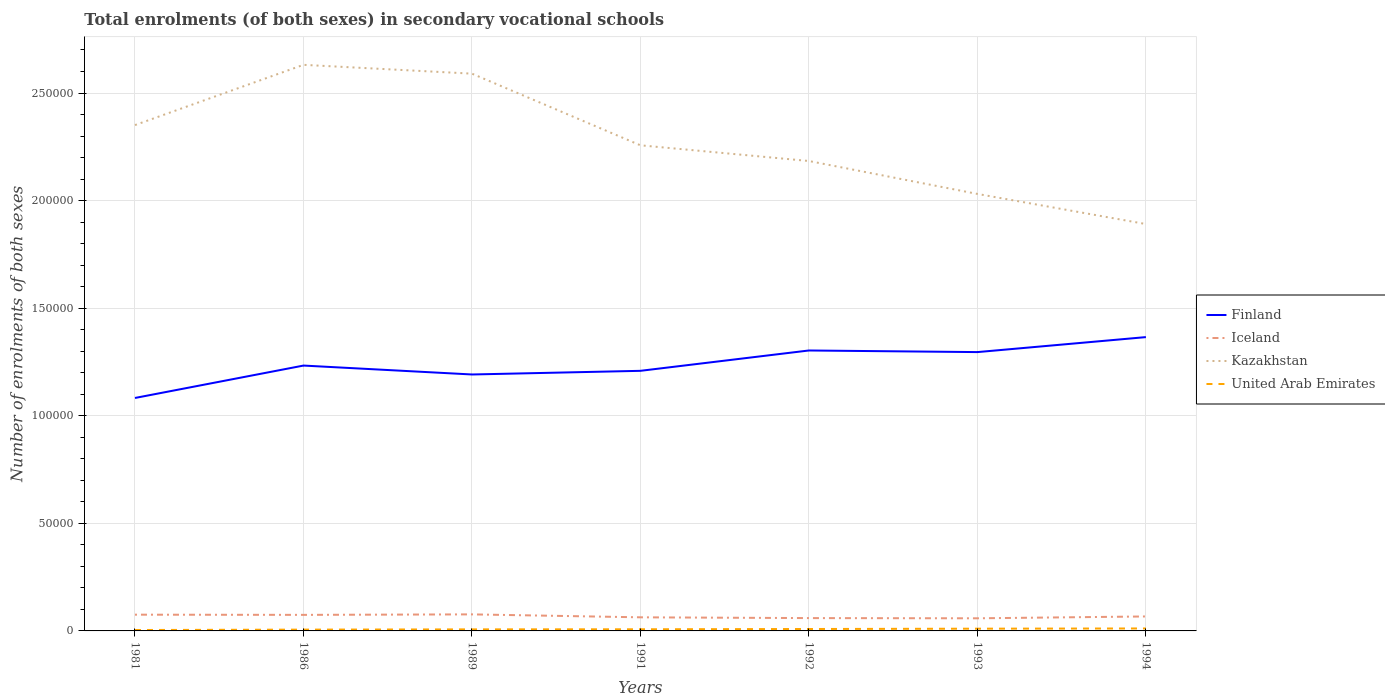How many different coloured lines are there?
Your answer should be very brief. 4. Does the line corresponding to Kazakhstan intersect with the line corresponding to Finland?
Keep it short and to the point. No. Is the number of lines equal to the number of legend labels?
Make the answer very short. Yes. Across all years, what is the maximum number of enrolments in secondary schools in Finland?
Provide a short and direct response. 1.08e+05. In which year was the number of enrolments in secondary schools in Kazakhstan maximum?
Keep it short and to the point. 1994. What is the total number of enrolments in secondary schools in United Arab Emirates in the graph?
Keep it short and to the point. -471. What is the difference between the highest and the second highest number of enrolments in secondary schools in Finland?
Your response must be concise. 2.83e+04. What is the difference between the highest and the lowest number of enrolments in secondary schools in Finland?
Your response must be concise. 3. What is the difference between two consecutive major ticks on the Y-axis?
Your response must be concise. 5.00e+04. How many legend labels are there?
Your answer should be compact. 4. What is the title of the graph?
Offer a very short reply. Total enrolments (of both sexes) in secondary vocational schools. What is the label or title of the Y-axis?
Your response must be concise. Number of enrolments of both sexes. What is the Number of enrolments of both sexes in Finland in 1981?
Your answer should be compact. 1.08e+05. What is the Number of enrolments of both sexes of Iceland in 1981?
Your response must be concise. 7552. What is the Number of enrolments of both sexes in Kazakhstan in 1981?
Provide a short and direct response. 2.35e+05. What is the Number of enrolments of both sexes in United Arab Emirates in 1981?
Offer a very short reply. 422. What is the Number of enrolments of both sexes of Finland in 1986?
Your answer should be very brief. 1.23e+05. What is the Number of enrolments of both sexes in Iceland in 1986?
Provide a succinct answer. 7462. What is the Number of enrolments of both sexes of Kazakhstan in 1986?
Your answer should be very brief. 2.63e+05. What is the Number of enrolments of both sexes of United Arab Emirates in 1986?
Provide a succinct answer. 604. What is the Number of enrolments of both sexes of Finland in 1989?
Ensure brevity in your answer.  1.19e+05. What is the Number of enrolments of both sexes of Iceland in 1989?
Give a very brief answer. 7689. What is the Number of enrolments of both sexes in Kazakhstan in 1989?
Make the answer very short. 2.59e+05. What is the Number of enrolments of both sexes in United Arab Emirates in 1989?
Your answer should be very brief. 720. What is the Number of enrolments of both sexes of Finland in 1991?
Your answer should be compact. 1.21e+05. What is the Number of enrolments of both sexes of Iceland in 1991?
Offer a very short reply. 6322. What is the Number of enrolments of both sexes in Kazakhstan in 1991?
Offer a terse response. 2.26e+05. What is the Number of enrolments of both sexes in United Arab Emirates in 1991?
Provide a short and direct response. 766. What is the Number of enrolments of both sexes of Finland in 1992?
Offer a very short reply. 1.30e+05. What is the Number of enrolments of both sexes of Iceland in 1992?
Provide a short and direct response. 5963. What is the Number of enrolments of both sexes of Kazakhstan in 1992?
Provide a short and direct response. 2.18e+05. What is the Number of enrolments of both sexes of United Arab Emirates in 1992?
Offer a very short reply. 893. What is the Number of enrolments of both sexes of Finland in 1993?
Your answer should be very brief. 1.30e+05. What is the Number of enrolments of both sexes in Iceland in 1993?
Give a very brief answer. 5865. What is the Number of enrolments of both sexes of Kazakhstan in 1993?
Offer a very short reply. 2.03e+05. What is the Number of enrolments of both sexes in United Arab Emirates in 1993?
Give a very brief answer. 1040. What is the Number of enrolments of both sexes in Finland in 1994?
Your answer should be very brief. 1.37e+05. What is the Number of enrolments of both sexes in Iceland in 1994?
Make the answer very short. 6726. What is the Number of enrolments of both sexes of Kazakhstan in 1994?
Offer a terse response. 1.89e+05. What is the Number of enrolments of both sexes of United Arab Emirates in 1994?
Your answer should be compact. 1143. Across all years, what is the maximum Number of enrolments of both sexes of Finland?
Your answer should be compact. 1.37e+05. Across all years, what is the maximum Number of enrolments of both sexes of Iceland?
Your answer should be compact. 7689. Across all years, what is the maximum Number of enrolments of both sexes of Kazakhstan?
Your answer should be compact. 2.63e+05. Across all years, what is the maximum Number of enrolments of both sexes in United Arab Emirates?
Offer a very short reply. 1143. Across all years, what is the minimum Number of enrolments of both sexes of Finland?
Offer a terse response. 1.08e+05. Across all years, what is the minimum Number of enrolments of both sexes in Iceland?
Give a very brief answer. 5865. Across all years, what is the minimum Number of enrolments of both sexes of Kazakhstan?
Keep it short and to the point. 1.89e+05. Across all years, what is the minimum Number of enrolments of both sexes of United Arab Emirates?
Offer a very short reply. 422. What is the total Number of enrolments of both sexes of Finland in the graph?
Offer a terse response. 8.68e+05. What is the total Number of enrolments of both sexes of Iceland in the graph?
Your answer should be very brief. 4.76e+04. What is the total Number of enrolments of both sexes in Kazakhstan in the graph?
Your answer should be very brief. 1.59e+06. What is the total Number of enrolments of both sexes in United Arab Emirates in the graph?
Give a very brief answer. 5588. What is the difference between the Number of enrolments of both sexes in Finland in 1981 and that in 1986?
Make the answer very short. -1.51e+04. What is the difference between the Number of enrolments of both sexes in Iceland in 1981 and that in 1986?
Your answer should be compact. 90. What is the difference between the Number of enrolments of both sexes in Kazakhstan in 1981 and that in 1986?
Make the answer very short. -2.80e+04. What is the difference between the Number of enrolments of both sexes of United Arab Emirates in 1981 and that in 1986?
Provide a succinct answer. -182. What is the difference between the Number of enrolments of both sexes in Finland in 1981 and that in 1989?
Offer a very short reply. -1.09e+04. What is the difference between the Number of enrolments of both sexes in Iceland in 1981 and that in 1989?
Keep it short and to the point. -137. What is the difference between the Number of enrolments of both sexes in Kazakhstan in 1981 and that in 1989?
Provide a succinct answer. -2.39e+04. What is the difference between the Number of enrolments of both sexes in United Arab Emirates in 1981 and that in 1989?
Your answer should be very brief. -298. What is the difference between the Number of enrolments of both sexes of Finland in 1981 and that in 1991?
Ensure brevity in your answer.  -1.26e+04. What is the difference between the Number of enrolments of both sexes in Iceland in 1981 and that in 1991?
Your response must be concise. 1230. What is the difference between the Number of enrolments of both sexes of Kazakhstan in 1981 and that in 1991?
Provide a short and direct response. 9400. What is the difference between the Number of enrolments of both sexes of United Arab Emirates in 1981 and that in 1991?
Offer a terse response. -344. What is the difference between the Number of enrolments of both sexes in Finland in 1981 and that in 1992?
Offer a very short reply. -2.21e+04. What is the difference between the Number of enrolments of both sexes of Iceland in 1981 and that in 1992?
Keep it short and to the point. 1589. What is the difference between the Number of enrolments of both sexes of Kazakhstan in 1981 and that in 1992?
Offer a very short reply. 1.67e+04. What is the difference between the Number of enrolments of both sexes of United Arab Emirates in 1981 and that in 1992?
Your answer should be compact. -471. What is the difference between the Number of enrolments of both sexes in Finland in 1981 and that in 1993?
Make the answer very short. -2.13e+04. What is the difference between the Number of enrolments of both sexes in Iceland in 1981 and that in 1993?
Give a very brief answer. 1687. What is the difference between the Number of enrolments of both sexes of Kazakhstan in 1981 and that in 1993?
Ensure brevity in your answer.  3.20e+04. What is the difference between the Number of enrolments of both sexes of United Arab Emirates in 1981 and that in 1993?
Ensure brevity in your answer.  -618. What is the difference between the Number of enrolments of both sexes of Finland in 1981 and that in 1994?
Your response must be concise. -2.83e+04. What is the difference between the Number of enrolments of both sexes in Iceland in 1981 and that in 1994?
Your answer should be very brief. 826. What is the difference between the Number of enrolments of both sexes of Kazakhstan in 1981 and that in 1994?
Offer a very short reply. 4.60e+04. What is the difference between the Number of enrolments of both sexes in United Arab Emirates in 1981 and that in 1994?
Give a very brief answer. -721. What is the difference between the Number of enrolments of both sexes of Finland in 1986 and that in 1989?
Give a very brief answer. 4141. What is the difference between the Number of enrolments of both sexes of Iceland in 1986 and that in 1989?
Ensure brevity in your answer.  -227. What is the difference between the Number of enrolments of both sexes of Kazakhstan in 1986 and that in 1989?
Your response must be concise. 4100. What is the difference between the Number of enrolments of both sexes of United Arab Emirates in 1986 and that in 1989?
Ensure brevity in your answer.  -116. What is the difference between the Number of enrolments of both sexes in Finland in 1986 and that in 1991?
Provide a short and direct response. 2443. What is the difference between the Number of enrolments of both sexes in Iceland in 1986 and that in 1991?
Your answer should be compact. 1140. What is the difference between the Number of enrolments of both sexes of Kazakhstan in 1986 and that in 1991?
Provide a succinct answer. 3.74e+04. What is the difference between the Number of enrolments of both sexes of United Arab Emirates in 1986 and that in 1991?
Keep it short and to the point. -162. What is the difference between the Number of enrolments of both sexes in Finland in 1986 and that in 1992?
Offer a very short reply. -7013. What is the difference between the Number of enrolments of both sexes of Iceland in 1986 and that in 1992?
Provide a succinct answer. 1499. What is the difference between the Number of enrolments of both sexes of Kazakhstan in 1986 and that in 1992?
Make the answer very short. 4.47e+04. What is the difference between the Number of enrolments of both sexes of United Arab Emirates in 1986 and that in 1992?
Your answer should be very brief. -289. What is the difference between the Number of enrolments of both sexes of Finland in 1986 and that in 1993?
Ensure brevity in your answer.  -6261. What is the difference between the Number of enrolments of both sexes in Iceland in 1986 and that in 1993?
Give a very brief answer. 1597. What is the difference between the Number of enrolments of both sexes of Kazakhstan in 1986 and that in 1993?
Keep it short and to the point. 6.00e+04. What is the difference between the Number of enrolments of both sexes in United Arab Emirates in 1986 and that in 1993?
Keep it short and to the point. -436. What is the difference between the Number of enrolments of both sexes of Finland in 1986 and that in 1994?
Offer a terse response. -1.32e+04. What is the difference between the Number of enrolments of both sexes in Iceland in 1986 and that in 1994?
Give a very brief answer. 736. What is the difference between the Number of enrolments of both sexes of Kazakhstan in 1986 and that in 1994?
Offer a terse response. 7.40e+04. What is the difference between the Number of enrolments of both sexes of United Arab Emirates in 1986 and that in 1994?
Provide a short and direct response. -539. What is the difference between the Number of enrolments of both sexes in Finland in 1989 and that in 1991?
Your response must be concise. -1698. What is the difference between the Number of enrolments of both sexes in Iceland in 1989 and that in 1991?
Provide a succinct answer. 1367. What is the difference between the Number of enrolments of both sexes of Kazakhstan in 1989 and that in 1991?
Your response must be concise. 3.33e+04. What is the difference between the Number of enrolments of both sexes in United Arab Emirates in 1989 and that in 1991?
Provide a succinct answer. -46. What is the difference between the Number of enrolments of both sexes of Finland in 1989 and that in 1992?
Offer a very short reply. -1.12e+04. What is the difference between the Number of enrolments of both sexes in Iceland in 1989 and that in 1992?
Provide a short and direct response. 1726. What is the difference between the Number of enrolments of both sexes in Kazakhstan in 1989 and that in 1992?
Your answer should be compact. 4.06e+04. What is the difference between the Number of enrolments of both sexes in United Arab Emirates in 1989 and that in 1992?
Provide a short and direct response. -173. What is the difference between the Number of enrolments of both sexes in Finland in 1989 and that in 1993?
Make the answer very short. -1.04e+04. What is the difference between the Number of enrolments of both sexes of Iceland in 1989 and that in 1993?
Your answer should be very brief. 1824. What is the difference between the Number of enrolments of both sexes of Kazakhstan in 1989 and that in 1993?
Give a very brief answer. 5.59e+04. What is the difference between the Number of enrolments of both sexes in United Arab Emirates in 1989 and that in 1993?
Ensure brevity in your answer.  -320. What is the difference between the Number of enrolments of both sexes of Finland in 1989 and that in 1994?
Offer a terse response. -1.74e+04. What is the difference between the Number of enrolments of both sexes of Iceland in 1989 and that in 1994?
Make the answer very short. 963. What is the difference between the Number of enrolments of both sexes in Kazakhstan in 1989 and that in 1994?
Offer a terse response. 6.99e+04. What is the difference between the Number of enrolments of both sexes of United Arab Emirates in 1989 and that in 1994?
Provide a short and direct response. -423. What is the difference between the Number of enrolments of both sexes of Finland in 1991 and that in 1992?
Offer a terse response. -9456. What is the difference between the Number of enrolments of both sexes in Iceland in 1991 and that in 1992?
Ensure brevity in your answer.  359. What is the difference between the Number of enrolments of both sexes of Kazakhstan in 1991 and that in 1992?
Ensure brevity in your answer.  7300. What is the difference between the Number of enrolments of both sexes of United Arab Emirates in 1991 and that in 1992?
Offer a very short reply. -127. What is the difference between the Number of enrolments of both sexes in Finland in 1991 and that in 1993?
Provide a short and direct response. -8704. What is the difference between the Number of enrolments of both sexes of Iceland in 1991 and that in 1993?
Your answer should be compact. 457. What is the difference between the Number of enrolments of both sexes of Kazakhstan in 1991 and that in 1993?
Provide a succinct answer. 2.26e+04. What is the difference between the Number of enrolments of both sexes in United Arab Emirates in 1991 and that in 1993?
Offer a terse response. -274. What is the difference between the Number of enrolments of both sexes in Finland in 1991 and that in 1994?
Give a very brief answer. -1.57e+04. What is the difference between the Number of enrolments of both sexes of Iceland in 1991 and that in 1994?
Offer a very short reply. -404. What is the difference between the Number of enrolments of both sexes in Kazakhstan in 1991 and that in 1994?
Provide a short and direct response. 3.66e+04. What is the difference between the Number of enrolments of both sexes in United Arab Emirates in 1991 and that in 1994?
Your answer should be very brief. -377. What is the difference between the Number of enrolments of both sexes of Finland in 1992 and that in 1993?
Keep it short and to the point. 752. What is the difference between the Number of enrolments of both sexes of Iceland in 1992 and that in 1993?
Make the answer very short. 98. What is the difference between the Number of enrolments of both sexes of Kazakhstan in 1992 and that in 1993?
Offer a terse response. 1.53e+04. What is the difference between the Number of enrolments of both sexes of United Arab Emirates in 1992 and that in 1993?
Keep it short and to the point. -147. What is the difference between the Number of enrolments of both sexes of Finland in 1992 and that in 1994?
Your answer should be very brief. -6212. What is the difference between the Number of enrolments of both sexes in Iceland in 1992 and that in 1994?
Your answer should be compact. -763. What is the difference between the Number of enrolments of both sexes of Kazakhstan in 1992 and that in 1994?
Your response must be concise. 2.93e+04. What is the difference between the Number of enrolments of both sexes in United Arab Emirates in 1992 and that in 1994?
Ensure brevity in your answer.  -250. What is the difference between the Number of enrolments of both sexes of Finland in 1993 and that in 1994?
Give a very brief answer. -6964. What is the difference between the Number of enrolments of both sexes in Iceland in 1993 and that in 1994?
Provide a short and direct response. -861. What is the difference between the Number of enrolments of both sexes in Kazakhstan in 1993 and that in 1994?
Your answer should be very brief. 1.40e+04. What is the difference between the Number of enrolments of both sexes of United Arab Emirates in 1993 and that in 1994?
Offer a terse response. -103. What is the difference between the Number of enrolments of both sexes of Finland in 1981 and the Number of enrolments of both sexes of Iceland in 1986?
Provide a short and direct response. 1.01e+05. What is the difference between the Number of enrolments of both sexes of Finland in 1981 and the Number of enrolments of both sexes of Kazakhstan in 1986?
Provide a succinct answer. -1.55e+05. What is the difference between the Number of enrolments of both sexes in Finland in 1981 and the Number of enrolments of both sexes in United Arab Emirates in 1986?
Your response must be concise. 1.08e+05. What is the difference between the Number of enrolments of both sexes in Iceland in 1981 and the Number of enrolments of both sexes in Kazakhstan in 1986?
Offer a terse response. -2.56e+05. What is the difference between the Number of enrolments of both sexes in Iceland in 1981 and the Number of enrolments of both sexes in United Arab Emirates in 1986?
Your response must be concise. 6948. What is the difference between the Number of enrolments of both sexes in Kazakhstan in 1981 and the Number of enrolments of both sexes in United Arab Emirates in 1986?
Your answer should be compact. 2.34e+05. What is the difference between the Number of enrolments of both sexes in Finland in 1981 and the Number of enrolments of both sexes in Iceland in 1989?
Make the answer very short. 1.01e+05. What is the difference between the Number of enrolments of both sexes of Finland in 1981 and the Number of enrolments of both sexes of Kazakhstan in 1989?
Give a very brief answer. -1.51e+05. What is the difference between the Number of enrolments of both sexes of Finland in 1981 and the Number of enrolments of both sexes of United Arab Emirates in 1989?
Give a very brief answer. 1.08e+05. What is the difference between the Number of enrolments of both sexes of Iceland in 1981 and the Number of enrolments of both sexes of Kazakhstan in 1989?
Make the answer very short. -2.51e+05. What is the difference between the Number of enrolments of both sexes of Iceland in 1981 and the Number of enrolments of both sexes of United Arab Emirates in 1989?
Offer a very short reply. 6832. What is the difference between the Number of enrolments of both sexes in Kazakhstan in 1981 and the Number of enrolments of both sexes in United Arab Emirates in 1989?
Your answer should be very brief. 2.34e+05. What is the difference between the Number of enrolments of both sexes of Finland in 1981 and the Number of enrolments of both sexes of Iceland in 1991?
Provide a short and direct response. 1.02e+05. What is the difference between the Number of enrolments of both sexes in Finland in 1981 and the Number of enrolments of both sexes in Kazakhstan in 1991?
Provide a succinct answer. -1.17e+05. What is the difference between the Number of enrolments of both sexes in Finland in 1981 and the Number of enrolments of both sexes in United Arab Emirates in 1991?
Offer a very short reply. 1.08e+05. What is the difference between the Number of enrolments of both sexes of Iceland in 1981 and the Number of enrolments of both sexes of Kazakhstan in 1991?
Your answer should be very brief. -2.18e+05. What is the difference between the Number of enrolments of both sexes of Iceland in 1981 and the Number of enrolments of both sexes of United Arab Emirates in 1991?
Provide a short and direct response. 6786. What is the difference between the Number of enrolments of both sexes in Kazakhstan in 1981 and the Number of enrolments of both sexes in United Arab Emirates in 1991?
Provide a short and direct response. 2.34e+05. What is the difference between the Number of enrolments of both sexes of Finland in 1981 and the Number of enrolments of both sexes of Iceland in 1992?
Give a very brief answer. 1.02e+05. What is the difference between the Number of enrolments of both sexes of Finland in 1981 and the Number of enrolments of both sexes of Kazakhstan in 1992?
Your answer should be very brief. -1.10e+05. What is the difference between the Number of enrolments of both sexes in Finland in 1981 and the Number of enrolments of both sexes in United Arab Emirates in 1992?
Your answer should be very brief. 1.07e+05. What is the difference between the Number of enrolments of both sexes in Iceland in 1981 and the Number of enrolments of both sexes in Kazakhstan in 1992?
Your answer should be compact. -2.11e+05. What is the difference between the Number of enrolments of both sexes of Iceland in 1981 and the Number of enrolments of both sexes of United Arab Emirates in 1992?
Give a very brief answer. 6659. What is the difference between the Number of enrolments of both sexes of Kazakhstan in 1981 and the Number of enrolments of both sexes of United Arab Emirates in 1992?
Your answer should be compact. 2.34e+05. What is the difference between the Number of enrolments of both sexes of Finland in 1981 and the Number of enrolments of both sexes of Iceland in 1993?
Offer a very short reply. 1.02e+05. What is the difference between the Number of enrolments of both sexes in Finland in 1981 and the Number of enrolments of both sexes in Kazakhstan in 1993?
Ensure brevity in your answer.  -9.48e+04. What is the difference between the Number of enrolments of both sexes of Finland in 1981 and the Number of enrolments of both sexes of United Arab Emirates in 1993?
Your answer should be very brief. 1.07e+05. What is the difference between the Number of enrolments of both sexes in Iceland in 1981 and the Number of enrolments of both sexes in Kazakhstan in 1993?
Your answer should be compact. -1.96e+05. What is the difference between the Number of enrolments of both sexes in Iceland in 1981 and the Number of enrolments of both sexes in United Arab Emirates in 1993?
Provide a short and direct response. 6512. What is the difference between the Number of enrolments of both sexes of Kazakhstan in 1981 and the Number of enrolments of both sexes of United Arab Emirates in 1993?
Offer a terse response. 2.34e+05. What is the difference between the Number of enrolments of both sexes of Finland in 1981 and the Number of enrolments of both sexes of Iceland in 1994?
Ensure brevity in your answer.  1.02e+05. What is the difference between the Number of enrolments of both sexes in Finland in 1981 and the Number of enrolments of both sexes in Kazakhstan in 1994?
Give a very brief answer. -8.08e+04. What is the difference between the Number of enrolments of both sexes of Finland in 1981 and the Number of enrolments of both sexes of United Arab Emirates in 1994?
Offer a very short reply. 1.07e+05. What is the difference between the Number of enrolments of both sexes of Iceland in 1981 and the Number of enrolments of both sexes of Kazakhstan in 1994?
Offer a very short reply. -1.82e+05. What is the difference between the Number of enrolments of both sexes in Iceland in 1981 and the Number of enrolments of both sexes in United Arab Emirates in 1994?
Provide a short and direct response. 6409. What is the difference between the Number of enrolments of both sexes of Kazakhstan in 1981 and the Number of enrolments of both sexes of United Arab Emirates in 1994?
Keep it short and to the point. 2.34e+05. What is the difference between the Number of enrolments of both sexes of Finland in 1986 and the Number of enrolments of both sexes of Iceland in 1989?
Ensure brevity in your answer.  1.16e+05. What is the difference between the Number of enrolments of both sexes of Finland in 1986 and the Number of enrolments of both sexes of Kazakhstan in 1989?
Offer a very short reply. -1.36e+05. What is the difference between the Number of enrolments of both sexes in Finland in 1986 and the Number of enrolments of both sexes in United Arab Emirates in 1989?
Provide a short and direct response. 1.23e+05. What is the difference between the Number of enrolments of both sexes in Iceland in 1986 and the Number of enrolments of both sexes in Kazakhstan in 1989?
Your response must be concise. -2.52e+05. What is the difference between the Number of enrolments of both sexes of Iceland in 1986 and the Number of enrolments of both sexes of United Arab Emirates in 1989?
Offer a very short reply. 6742. What is the difference between the Number of enrolments of both sexes of Kazakhstan in 1986 and the Number of enrolments of both sexes of United Arab Emirates in 1989?
Ensure brevity in your answer.  2.62e+05. What is the difference between the Number of enrolments of both sexes in Finland in 1986 and the Number of enrolments of both sexes in Iceland in 1991?
Give a very brief answer. 1.17e+05. What is the difference between the Number of enrolments of both sexes of Finland in 1986 and the Number of enrolments of both sexes of Kazakhstan in 1991?
Give a very brief answer. -1.02e+05. What is the difference between the Number of enrolments of both sexes of Finland in 1986 and the Number of enrolments of both sexes of United Arab Emirates in 1991?
Offer a very short reply. 1.23e+05. What is the difference between the Number of enrolments of both sexes of Iceland in 1986 and the Number of enrolments of both sexes of Kazakhstan in 1991?
Keep it short and to the point. -2.18e+05. What is the difference between the Number of enrolments of both sexes in Iceland in 1986 and the Number of enrolments of both sexes in United Arab Emirates in 1991?
Offer a terse response. 6696. What is the difference between the Number of enrolments of both sexes in Kazakhstan in 1986 and the Number of enrolments of both sexes in United Arab Emirates in 1991?
Keep it short and to the point. 2.62e+05. What is the difference between the Number of enrolments of both sexes in Finland in 1986 and the Number of enrolments of both sexes in Iceland in 1992?
Make the answer very short. 1.17e+05. What is the difference between the Number of enrolments of both sexes in Finland in 1986 and the Number of enrolments of both sexes in Kazakhstan in 1992?
Make the answer very short. -9.51e+04. What is the difference between the Number of enrolments of both sexes in Finland in 1986 and the Number of enrolments of both sexes in United Arab Emirates in 1992?
Provide a succinct answer. 1.22e+05. What is the difference between the Number of enrolments of both sexes in Iceland in 1986 and the Number of enrolments of both sexes in Kazakhstan in 1992?
Provide a short and direct response. -2.11e+05. What is the difference between the Number of enrolments of both sexes in Iceland in 1986 and the Number of enrolments of both sexes in United Arab Emirates in 1992?
Your answer should be compact. 6569. What is the difference between the Number of enrolments of both sexes in Kazakhstan in 1986 and the Number of enrolments of both sexes in United Arab Emirates in 1992?
Provide a succinct answer. 2.62e+05. What is the difference between the Number of enrolments of both sexes in Finland in 1986 and the Number of enrolments of both sexes in Iceland in 1993?
Make the answer very short. 1.17e+05. What is the difference between the Number of enrolments of both sexes of Finland in 1986 and the Number of enrolments of both sexes of Kazakhstan in 1993?
Give a very brief answer. -7.98e+04. What is the difference between the Number of enrolments of both sexes in Finland in 1986 and the Number of enrolments of both sexes in United Arab Emirates in 1993?
Provide a short and direct response. 1.22e+05. What is the difference between the Number of enrolments of both sexes of Iceland in 1986 and the Number of enrolments of both sexes of Kazakhstan in 1993?
Provide a succinct answer. -1.96e+05. What is the difference between the Number of enrolments of both sexes of Iceland in 1986 and the Number of enrolments of both sexes of United Arab Emirates in 1993?
Offer a very short reply. 6422. What is the difference between the Number of enrolments of both sexes in Kazakhstan in 1986 and the Number of enrolments of both sexes in United Arab Emirates in 1993?
Ensure brevity in your answer.  2.62e+05. What is the difference between the Number of enrolments of both sexes in Finland in 1986 and the Number of enrolments of both sexes in Iceland in 1994?
Make the answer very short. 1.17e+05. What is the difference between the Number of enrolments of both sexes in Finland in 1986 and the Number of enrolments of both sexes in Kazakhstan in 1994?
Your response must be concise. -6.58e+04. What is the difference between the Number of enrolments of both sexes in Finland in 1986 and the Number of enrolments of both sexes in United Arab Emirates in 1994?
Your answer should be compact. 1.22e+05. What is the difference between the Number of enrolments of both sexes in Iceland in 1986 and the Number of enrolments of both sexes in Kazakhstan in 1994?
Your response must be concise. -1.82e+05. What is the difference between the Number of enrolments of both sexes in Iceland in 1986 and the Number of enrolments of both sexes in United Arab Emirates in 1994?
Give a very brief answer. 6319. What is the difference between the Number of enrolments of both sexes in Kazakhstan in 1986 and the Number of enrolments of both sexes in United Arab Emirates in 1994?
Offer a very short reply. 2.62e+05. What is the difference between the Number of enrolments of both sexes in Finland in 1989 and the Number of enrolments of both sexes in Iceland in 1991?
Offer a very short reply. 1.13e+05. What is the difference between the Number of enrolments of both sexes of Finland in 1989 and the Number of enrolments of both sexes of Kazakhstan in 1991?
Provide a short and direct response. -1.07e+05. What is the difference between the Number of enrolments of both sexes of Finland in 1989 and the Number of enrolments of both sexes of United Arab Emirates in 1991?
Offer a very short reply. 1.18e+05. What is the difference between the Number of enrolments of both sexes in Iceland in 1989 and the Number of enrolments of both sexes in Kazakhstan in 1991?
Your response must be concise. -2.18e+05. What is the difference between the Number of enrolments of both sexes in Iceland in 1989 and the Number of enrolments of both sexes in United Arab Emirates in 1991?
Keep it short and to the point. 6923. What is the difference between the Number of enrolments of both sexes of Kazakhstan in 1989 and the Number of enrolments of both sexes of United Arab Emirates in 1991?
Provide a short and direct response. 2.58e+05. What is the difference between the Number of enrolments of both sexes of Finland in 1989 and the Number of enrolments of both sexes of Iceland in 1992?
Offer a terse response. 1.13e+05. What is the difference between the Number of enrolments of both sexes of Finland in 1989 and the Number of enrolments of both sexes of Kazakhstan in 1992?
Offer a very short reply. -9.92e+04. What is the difference between the Number of enrolments of both sexes in Finland in 1989 and the Number of enrolments of both sexes in United Arab Emirates in 1992?
Your answer should be compact. 1.18e+05. What is the difference between the Number of enrolments of both sexes in Iceland in 1989 and the Number of enrolments of both sexes in Kazakhstan in 1992?
Offer a very short reply. -2.11e+05. What is the difference between the Number of enrolments of both sexes in Iceland in 1989 and the Number of enrolments of both sexes in United Arab Emirates in 1992?
Your answer should be very brief. 6796. What is the difference between the Number of enrolments of both sexes in Kazakhstan in 1989 and the Number of enrolments of both sexes in United Arab Emirates in 1992?
Your answer should be very brief. 2.58e+05. What is the difference between the Number of enrolments of both sexes in Finland in 1989 and the Number of enrolments of both sexes in Iceland in 1993?
Give a very brief answer. 1.13e+05. What is the difference between the Number of enrolments of both sexes in Finland in 1989 and the Number of enrolments of both sexes in Kazakhstan in 1993?
Your response must be concise. -8.39e+04. What is the difference between the Number of enrolments of both sexes in Finland in 1989 and the Number of enrolments of both sexes in United Arab Emirates in 1993?
Make the answer very short. 1.18e+05. What is the difference between the Number of enrolments of both sexes of Iceland in 1989 and the Number of enrolments of both sexes of Kazakhstan in 1993?
Keep it short and to the point. -1.95e+05. What is the difference between the Number of enrolments of both sexes of Iceland in 1989 and the Number of enrolments of both sexes of United Arab Emirates in 1993?
Offer a very short reply. 6649. What is the difference between the Number of enrolments of both sexes of Kazakhstan in 1989 and the Number of enrolments of both sexes of United Arab Emirates in 1993?
Ensure brevity in your answer.  2.58e+05. What is the difference between the Number of enrolments of both sexes in Finland in 1989 and the Number of enrolments of both sexes in Iceland in 1994?
Your answer should be very brief. 1.12e+05. What is the difference between the Number of enrolments of both sexes in Finland in 1989 and the Number of enrolments of both sexes in Kazakhstan in 1994?
Ensure brevity in your answer.  -6.99e+04. What is the difference between the Number of enrolments of both sexes of Finland in 1989 and the Number of enrolments of both sexes of United Arab Emirates in 1994?
Offer a very short reply. 1.18e+05. What is the difference between the Number of enrolments of both sexes of Iceland in 1989 and the Number of enrolments of both sexes of Kazakhstan in 1994?
Offer a very short reply. -1.81e+05. What is the difference between the Number of enrolments of both sexes of Iceland in 1989 and the Number of enrolments of both sexes of United Arab Emirates in 1994?
Provide a short and direct response. 6546. What is the difference between the Number of enrolments of both sexes in Kazakhstan in 1989 and the Number of enrolments of both sexes in United Arab Emirates in 1994?
Make the answer very short. 2.58e+05. What is the difference between the Number of enrolments of both sexes of Finland in 1991 and the Number of enrolments of both sexes of Iceland in 1992?
Your answer should be compact. 1.15e+05. What is the difference between the Number of enrolments of both sexes in Finland in 1991 and the Number of enrolments of both sexes in Kazakhstan in 1992?
Ensure brevity in your answer.  -9.75e+04. What is the difference between the Number of enrolments of both sexes of Finland in 1991 and the Number of enrolments of both sexes of United Arab Emirates in 1992?
Offer a very short reply. 1.20e+05. What is the difference between the Number of enrolments of both sexes in Iceland in 1991 and the Number of enrolments of both sexes in Kazakhstan in 1992?
Your answer should be very brief. -2.12e+05. What is the difference between the Number of enrolments of both sexes in Iceland in 1991 and the Number of enrolments of both sexes in United Arab Emirates in 1992?
Make the answer very short. 5429. What is the difference between the Number of enrolments of both sexes of Kazakhstan in 1991 and the Number of enrolments of both sexes of United Arab Emirates in 1992?
Offer a terse response. 2.25e+05. What is the difference between the Number of enrolments of both sexes in Finland in 1991 and the Number of enrolments of both sexes in Iceland in 1993?
Offer a very short reply. 1.15e+05. What is the difference between the Number of enrolments of both sexes in Finland in 1991 and the Number of enrolments of both sexes in Kazakhstan in 1993?
Provide a succinct answer. -8.22e+04. What is the difference between the Number of enrolments of both sexes of Finland in 1991 and the Number of enrolments of both sexes of United Arab Emirates in 1993?
Provide a short and direct response. 1.20e+05. What is the difference between the Number of enrolments of both sexes of Iceland in 1991 and the Number of enrolments of both sexes of Kazakhstan in 1993?
Provide a short and direct response. -1.97e+05. What is the difference between the Number of enrolments of both sexes of Iceland in 1991 and the Number of enrolments of both sexes of United Arab Emirates in 1993?
Make the answer very short. 5282. What is the difference between the Number of enrolments of both sexes in Kazakhstan in 1991 and the Number of enrolments of both sexes in United Arab Emirates in 1993?
Keep it short and to the point. 2.25e+05. What is the difference between the Number of enrolments of both sexes of Finland in 1991 and the Number of enrolments of both sexes of Iceland in 1994?
Your answer should be very brief. 1.14e+05. What is the difference between the Number of enrolments of both sexes in Finland in 1991 and the Number of enrolments of both sexes in Kazakhstan in 1994?
Your response must be concise. -6.82e+04. What is the difference between the Number of enrolments of both sexes in Finland in 1991 and the Number of enrolments of both sexes in United Arab Emirates in 1994?
Offer a terse response. 1.20e+05. What is the difference between the Number of enrolments of both sexes of Iceland in 1991 and the Number of enrolments of both sexes of Kazakhstan in 1994?
Keep it short and to the point. -1.83e+05. What is the difference between the Number of enrolments of both sexes of Iceland in 1991 and the Number of enrolments of both sexes of United Arab Emirates in 1994?
Your answer should be very brief. 5179. What is the difference between the Number of enrolments of both sexes of Kazakhstan in 1991 and the Number of enrolments of both sexes of United Arab Emirates in 1994?
Your answer should be compact. 2.25e+05. What is the difference between the Number of enrolments of both sexes of Finland in 1992 and the Number of enrolments of both sexes of Iceland in 1993?
Keep it short and to the point. 1.24e+05. What is the difference between the Number of enrolments of both sexes of Finland in 1992 and the Number of enrolments of both sexes of Kazakhstan in 1993?
Provide a short and direct response. -7.28e+04. What is the difference between the Number of enrolments of both sexes of Finland in 1992 and the Number of enrolments of both sexes of United Arab Emirates in 1993?
Your answer should be compact. 1.29e+05. What is the difference between the Number of enrolments of both sexes of Iceland in 1992 and the Number of enrolments of both sexes of Kazakhstan in 1993?
Ensure brevity in your answer.  -1.97e+05. What is the difference between the Number of enrolments of both sexes in Iceland in 1992 and the Number of enrolments of both sexes in United Arab Emirates in 1993?
Give a very brief answer. 4923. What is the difference between the Number of enrolments of both sexes of Kazakhstan in 1992 and the Number of enrolments of both sexes of United Arab Emirates in 1993?
Make the answer very short. 2.17e+05. What is the difference between the Number of enrolments of both sexes in Finland in 1992 and the Number of enrolments of both sexes in Iceland in 1994?
Your answer should be very brief. 1.24e+05. What is the difference between the Number of enrolments of both sexes in Finland in 1992 and the Number of enrolments of both sexes in Kazakhstan in 1994?
Ensure brevity in your answer.  -5.88e+04. What is the difference between the Number of enrolments of both sexes of Finland in 1992 and the Number of enrolments of both sexes of United Arab Emirates in 1994?
Offer a terse response. 1.29e+05. What is the difference between the Number of enrolments of both sexes in Iceland in 1992 and the Number of enrolments of both sexes in Kazakhstan in 1994?
Your response must be concise. -1.83e+05. What is the difference between the Number of enrolments of both sexes of Iceland in 1992 and the Number of enrolments of both sexes of United Arab Emirates in 1994?
Your answer should be very brief. 4820. What is the difference between the Number of enrolments of both sexes in Kazakhstan in 1992 and the Number of enrolments of both sexes in United Arab Emirates in 1994?
Your answer should be compact. 2.17e+05. What is the difference between the Number of enrolments of both sexes in Finland in 1993 and the Number of enrolments of both sexes in Iceland in 1994?
Provide a short and direct response. 1.23e+05. What is the difference between the Number of enrolments of both sexes of Finland in 1993 and the Number of enrolments of both sexes of Kazakhstan in 1994?
Offer a terse response. -5.95e+04. What is the difference between the Number of enrolments of both sexes in Finland in 1993 and the Number of enrolments of both sexes in United Arab Emirates in 1994?
Ensure brevity in your answer.  1.28e+05. What is the difference between the Number of enrolments of both sexes of Iceland in 1993 and the Number of enrolments of both sexes of Kazakhstan in 1994?
Provide a short and direct response. -1.83e+05. What is the difference between the Number of enrolments of both sexes in Iceland in 1993 and the Number of enrolments of both sexes in United Arab Emirates in 1994?
Give a very brief answer. 4722. What is the difference between the Number of enrolments of both sexes in Kazakhstan in 1993 and the Number of enrolments of both sexes in United Arab Emirates in 1994?
Provide a succinct answer. 2.02e+05. What is the average Number of enrolments of both sexes in Finland per year?
Offer a terse response. 1.24e+05. What is the average Number of enrolments of both sexes in Iceland per year?
Your response must be concise. 6797. What is the average Number of enrolments of both sexes in Kazakhstan per year?
Your answer should be compact. 2.28e+05. What is the average Number of enrolments of both sexes of United Arab Emirates per year?
Make the answer very short. 798.29. In the year 1981, what is the difference between the Number of enrolments of both sexes of Finland and Number of enrolments of both sexes of Iceland?
Your answer should be compact. 1.01e+05. In the year 1981, what is the difference between the Number of enrolments of both sexes in Finland and Number of enrolments of both sexes in Kazakhstan?
Provide a short and direct response. -1.27e+05. In the year 1981, what is the difference between the Number of enrolments of both sexes in Finland and Number of enrolments of both sexes in United Arab Emirates?
Keep it short and to the point. 1.08e+05. In the year 1981, what is the difference between the Number of enrolments of both sexes in Iceland and Number of enrolments of both sexes in Kazakhstan?
Give a very brief answer. -2.28e+05. In the year 1981, what is the difference between the Number of enrolments of both sexes of Iceland and Number of enrolments of both sexes of United Arab Emirates?
Give a very brief answer. 7130. In the year 1981, what is the difference between the Number of enrolments of both sexes of Kazakhstan and Number of enrolments of both sexes of United Arab Emirates?
Offer a terse response. 2.35e+05. In the year 1986, what is the difference between the Number of enrolments of both sexes of Finland and Number of enrolments of both sexes of Iceland?
Keep it short and to the point. 1.16e+05. In the year 1986, what is the difference between the Number of enrolments of both sexes in Finland and Number of enrolments of both sexes in Kazakhstan?
Provide a short and direct response. -1.40e+05. In the year 1986, what is the difference between the Number of enrolments of both sexes in Finland and Number of enrolments of both sexes in United Arab Emirates?
Give a very brief answer. 1.23e+05. In the year 1986, what is the difference between the Number of enrolments of both sexes in Iceland and Number of enrolments of both sexes in Kazakhstan?
Offer a very short reply. -2.56e+05. In the year 1986, what is the difference between the Number of enrolments of both sexes in Iceland and Number of enrolments of both sexes in United Arab Emirates?
Give a very brief answer. 6858. In the year 1986, what is the difference between the Number of enrolments of both sexes in Kazakhstan and Number of enrolments of both sexes in United Arab Emirates?
Keep it short and to the point. 2.62e+05. In the year 1989, what is the difference between the Number of enrolments of both sexes in Finland and Number of enrolments of both sexes in Iceland?
Your answer should be compact. 1.11e+05. In the year 1989, what is the difference between the Number of enrolments of both sexes of Finland and Number of enrolments of both sexes of Kazakhstan?
Offer a terse response. -1.40e+05. In the year 1989, what is the difference between the Number of enrolments of both sexes in Finland and Number of enrolments of both sexes in United Arab Emirates?
Make the answer very short. 1.18e+05. In the year 1989, what is the difference between the Number of enrolments of both sexes in Iceland and Number of enrolments of both sexes in Kazakhstan?
Give a very brief answer. -2.51e+05. In the year 1989, what is the difference between the Number of enrolments of both sexes of Iceland and Number of enrolments of both sexes of United Arab Emirates?
Your answer should be compact. 6969. In the year 1989, what is the difference between the Number of enrolments of both sexes in Kazakhstan and Number of enrolments of both sexes in United Arab Emirates?
Make the answer very short. 2.58e+05. In the year 1991, what is the difference between the Number of enrolments of both sexes in Finland and Number of enrolments of both sexes in Iceland?
Ensure brevity in your answer.  1.15e+05. In the year 1991, what is the difference between the Number of enrolments of both sexes of Finland and Number of enrolments of both sexes of Kazakhstan?
Offer a terse response. -1.05e+05. In the year 1991, what is the difference between the Number of enrolments of both sexes in Finland and Number of enrolments of both sexes in United Arab Emirates?
Your answer should be very brief. 1.20e+05. In the year 1991, what is the difference between the Number of enrolments of both sexes in Iceland and Number of enrolments of both sexes in Kazakhstan?
Provide a succinct answer. -2.19e+05. In the year 1991, what is the difference between the Number of enrolments of both sexes of Iceland and Number of enrolments of both sexes of United Arab Emirates?
Offer a very short reply. 5556. In the year 1991, what is the difference between the Number of enrolments of both sexes of Kazakhstan and Number of enrolments of both sexes of United Arab Emirates?
Provide a short and direct response. 2.25e+05. In the year 1992, what is the difference between the Number of enrolments of both sexes in Finland and Number of enrolments of both sexes in Iceland?
Provide a short and direct response. 1.24e+05. In the year 1992, what is the difference between the Number of enrolments of both sexes of Finland and Number of enrolments of both sexes of Kazakhstan?
Your response must be concise. -8.81e+04. In the year 1992, what is the difference between the Number of enrolments of both sexes of Finland and Number of enrolments of both sexes of United Arab Emirates?
Provide a succinct answer. 1.29e+05. In the year 1992, what is the difference between the Number of enrolments of both sexes in Iceland and Number of enrolments of both sexes in Kazakhstan?
Give a very brief answer. -2.12e+05. In the year 1992, what is the difference between the Number of enrolments of both sexes of Iceland and Number of enrolments of both sexes of United Arab Emirates?
Your answer should be very brief. 5070. In the year 1992, what is the difference between the Number of enrolments of both sexes of Kazakhstan and Number of enrolments of both sexes of United Arab Emirates?
Your answer should be compact. 2.18e+05. In the year 1993, what is the difference between the Number of enrolments of both sexes of Finland and Number of enrolments of both sexes of Iceland?
Provide a short and direct response. 1.24e+05. In the year 1993, what is the difference between the Number of enrolments of both sexes in Finland and Number of enrolments of both sexes in Kazakhstan?
Make the answer very short. -7.35e+04. In the year 1993, what is the difference between the Number of enrolments of both sexes of Finland and Number of enrolments of both sexes of United Arab Emirates?
Offer a very short reply. 1.29e+05. In the year 1993, what is the difference between the Number of enrolments of both sexes in Iceland and Number of enrolments of both sexes in Kazakhstan?
Give a very brief answer. -1.97e+05. In the year 1993, what is the difference between the Number of enrolments of both sexes in Iceland and Number of enrolments of both sexes in United Arab Emirates?
Provide a short and direct response. 4825. In the year 1993, what is the difference between the Number of enrolments of both sexes in Kazakhstan and Number of enrolments of both sexes in United Arab Emirates?
Your answer should be compact. 2.02e+05. In the year 1994, what is the difference between the Number of enrolments of both sexes of Finland and Number of enrolments of both sexes of Iceland?
Give a very brief answer. 1.30e+05. In the year 1994, what is the difference between the Number of enrolments of both sexes in Finland and Number of enrolments of both sexes in Kazakhstan?
Give a very brief answer. -5.25e+04. In the year 1994, what is the difference between the Number of enrolments of both sexes of Finland and Number of enrolments of both sexes of United Arab Emirates?
Give a very brief answer. 1.35e+05. In the year 1994, what is the difference between the Number of enrolments of both sexes of Iceland and Number of enrolments of both sexes of Kazakhstan?
Ensure brevity in your answer.  -1.82e+05. In the year 1994, what is the difference between the Number of enrolments of both sexes in Iceland and Number of enrolments of both sexes in United Arab Emirates?
Provide a short and direct response. 5583. In the year 1994, what is the difference between the Number of enrolments of both sexes in Kazakhstan and Number of enrolments of both sexes in United Arab Emirates?
Ensure brevity in your answer.  1.88e+05. What is the ratio of the Number of enrolments of both sexes of Finland in 1981 to that in 1986?
Make the answer very short. 0.88. What is the ratio of the Number of enrolments of both sexes of Iceland in 1981 to that in 1986?
Keep it short and to the point. 1.01. What is the ratio of the Number of enrolments of both sexes in Kazakhstan in 1981 to that in 1986?
Keep it short and to the point. 0.89. What is the ratio of the Number of enrolments of both sexes of United Arab Emirates in 1981 to that in 1986?
Provide a succinct answer. 0.7. What is the ratio of the Number of enrolments of both sexes in Finland in 1981 to that in 1989?
Provide a succinct answer. 0.91. What is the ratio of the Number of enrolments of both sexes in Iceland in 1981 to that in 1989?
Make the answer very short. 0.98. What is the ratio of the Number of enrolments of both sexes in Kazakhstan in 1981 to that in 1989?
Your response must be concise. 0.91. What is the ratio of the Number of enrolments of both sexes in United Arab Emirates in 1981 to that in 1989?
Offer a very short reply. 0.59. What is the ratio of the Number of enrolments of both sexes in Finland in 1981 to that in 1991?
Make the answer very short. 0.9. What is the ratio of the Number of enrolments of both sexes of Iceland in 1981 to that in 1991?
Ensure brevity in your answer.  1.19. What is the ratio of the Number of enrolments of both sexes in Kazakhstan in 1981 to that in 1991?
Offer a very short reply. 1.04. What is the ratio of the Number of enrolments of both sexes in United Arab Emirates in 1981 to that in 1991?
Provide a short and direct response. 0.55. What is the ratio of the Number of enrolments of both sexes in Finland in 1981 to that in 1992?
Your answer should be very brief. 0.83. What is the ratio of the Number of enrolments of both sexes of Iceland in 1981 to that in 1992?
Keep it short and to the point. 1.27. What is the ratio of the Number of enrolments of both sexes in Kazakhstan in 1981 to that in 1992?
Ensure brevity in your answer.  1.08. What is the ratio of the Number of enrolments of both sexes of United Arab Emirates in 1981 to that in 1992?
Your answer should be very brief. 0.47. What is the ratio of the Number of enrolments of both sexes of Finland in 1981 to that in 1993?
Provide a succinct answer. 0.84. What is the ratio of the Number of enrolments of both sexes in Iceland in 1981 to that in 1993?
Make the answer very short. 1.29. What is the ratio of the Number of enrolments of both sexes in Kazakhstan in 1981 to that in 1993?
Your answer should be very brief. 1.16. What is the ratio of the Number of enrolments of both sexes of United Arab Emirates in 1981 to that in 1993?
Ensure brevity in your answer.  0.41. What is the ratio of the Number of enrolments of both sexes of Finland in 1981 to that in 1994?
Give a very brief answer. 0.79. What is the ratio of the Number of enrolments of both sexes in Iceland in 1981 to that in 1994?
Provide a succinct answer. 1.12. What is the ratio of the Number of enrolments of both sexes in Kazakhstan in 1981 to that in 1994?
Your response must be concise. 1.24. What is the ratio of the Number of enrolments of both sexes of United Arab Emirates in 1981 to that in 1994?
Keep it short and to the point. 0.37. What is the ratio of the Number of enrolments of both sexes of Finland in 1986 to that in 1989?
Offer a terse response. 1.03. What is the ratio of the Number of enrolments of both sexes of Iceland in 1986 to that in 1989?
Give a very brief answer. 0.97. What is the ratio of the Number of enrolments of both sexes in Kazakhstan in 1986 to that in 1989?
Make the answer very short. 1.02. What is the ratio of the Number of enrolments of both sexes of United Arab Emirates in 1986 to that in 1989?
Your response must be concise. 0.84. What is the ratio of the Number of enrolments of both sexes in Finland in 1986 to that in 1991?
Keep it short and to the point. 1.02. What is the ratio of the Number of enrolments of both sexes in Iceland in 1986 to that in 1991?
Give a very brief answer. 1.18. What is the ratio of the Number of enrolments of both sexes of Kazakhstan in 1986 to that in 1991?
Make the answer very short. 1.17. What is the ratio of the Number of enrolments of both sexes in United Arab Emirates in 1986 to that in 1991?
Offer a very short reply. 0.79. What is the ratio of the Number of enrolments of both sexes in Finland in 1986 to that in 1992?
Provide a short and direct response. 0.95. What is the ratio of the Number of enrolments of both sexes of Iceland in 1986 to that in 1992?
Your answer should be compact. 1.25. What is the ratio of the Number of enrolments of both sexes in Kazakhstan in 1986 to that in 1992?
Offer a very short reply. 1.2. What is the ratio of the Number of enrolments of both sexes in United Arab Emirates in 1986 to that in 1992?
Ensure brevity in your answer.  0.68. What is the ratio of the Number of enrolments of both sexes in Finland in 1986 to that in 1993?
Provide a succinct answer. 0.95. What is the ratio of the Number of enrolments of both sexes in Iceland in 1986 to that in 1993?
Your answer should be very brief. 1.27. What is the ratio of the Number of enrolments of both sexes in Kazakhstan in 1986 to that in 1993?
Your answer should be very brief. 1.3. What is the ratio of the Number of enrolments of both sexes in United Arab Emirates in 1986 to that in 1993?
Your answer should be very brief. 0.58. What is the ratio of the Number of enrolments of both sexes in Finland in 1986 to that in 1994?
Your answer should be compact. 0.9. What is the ratio of the Number of enrolments of both sexes in Iceland in 1986 to that in 1994?
Give a very brief answer. 1.11. What is the ratio of the Number of enrolments of both sexes in Kazakhstan in 1986 to that in 1994?
Ensure brevity in your answer.  1.39. What is the ratio of the Number of enrolments of both sexes of United Arab Emirates in 1986 to that in 1994?
Offer a terse response. 0.53. What is the ratio of the Number of enrolments of both sexes of Iceland in 1989 to that in 1991?
Your answer should be very brief. 1.22. What is the ratio of the Number of enrolments of both sexes of Kazakhstan in 1989 to that in 1991?
Your answer should be very brief. 1.15. What is the ratio of the Number of enrolments of both sexes of United Arab Emirates in 1989 to that in 1991?
Make the answer very short. 0.94. What is the ratio of the Number of enrolments of both sexes in Finland in 1989 to that in 1992?
Your answer should be compact. 0.91. What is the ratio of the Number of enrolments of both sexes of Iceland in 1989 to that in 1992?
Ensure brevity in your answer.  1.29. What is the ratio of the Number of enrolments of both sexes of Kazakhstan in 1989 to that in 1992?
Offer a very short reply. 1.19. What is the ratio of the Number of enrolments of both sexes in United Arab Emirates in 1989 to that in 1992?
Provide a short and direct response. 0.81. What is the ratio of the Number of enrolments of both sexes of Finland in 1989 to that in 1993?
Your answer should be compact. 0.92. What is the ratio of the Number of enrolments of both sexes of Iceland in 1989 to that in 1993?
Give a very brief answer. 1.31. What is the ratio of the Number of enrolments of both sexes in Kazakhstan in 1989 to that in 1993?
Ensure brevity in your answer.  1.28. What is the ratio of the Number of enrolments of both sexes in United Arab Emirates in 1989 to that in 1993?
Ensure brevity in your answer.  0.69. What is the ratio of the Number of enrolments of both sexes in Finland in 1989 to that in 1994?
Give a very brief answer. 0.87. What is the ratio of the Number of enrolments of both sexes of Iceland in 1989 to that in 1994?
Provide a succinct answer. 1.14. What is the ratio of the Number of enrolments of both sexes in Kazakhstan in 1989 to that in 1994?
Your response must be concise. 1.37. What is the ratio of the Number of enrolments of both sexes of United Arab Emirates in 1989 to that in 1994?
Your answer should be very brief. 0.63. What is the ratio of the Number of enrolments of both sexes in Finland in 1991 to that in 1992?
Your answer should be very brief. 0.93. What is the ratio of the Number of enrolments of both sexes of Iceland in 1991 to that in 1992?
Provide a short and direct response. 1.06. What is the ratio of the Number of enrolments of both sexes in Kazakhstan in 1991 to that in 1992?
Provide a succinct answer. 1.03. What is the ratio of the Number of enrolments of both sexes in United Arab Emirates in 1991 to that in 1992?
Provide a short and direct response. 0.86. What is the ratio of the Number of enrolments of both sexes of Finland in 1991 to that in 1993?
Provide a short and direct response. 0.93. What is the ratio of the Number of enrolments of both sexes of Iceland in 1991 to that in 1993?
Give a very brief answer. 1.08. What is the ratio of the Number of enrolments of both sexes in Kazakhstan in 1991 to that in 1993?
Give a very brief answer. 1.11. What is the ratio of the Number of enrolments of both sexes of United Arab Emirates in 1991 to that in 1993?
Give a very brief answer. 0.74. What is the ratio of the Number of enrolments of both sexes in Finland in 1991 to that in 1994?
Offer a terse response. 0.89. What is the ratio of the Number of enrolments of both sexes of Iceland in 1991 to that in 1994?
Provide a succinct answer. 0.94. What is the ratio of the Number of enrolments of both sexes of Kazakhstan in 1991 to that in 1994?
Offer a very short reply. 1.19. What is the ratio of the Number of enrolments of both sexes in United Arab Emirates in 1991 to that in 1994?
Your response must be concise. 0.67. What is the ratio of the Number of enrolments of both sexes in Iceland in 1992 to that in 1993?
Your answer should be compact. 1.02. What is the ratio of the Number of enrolments of both sexes in Kazakhstan in 1992 to that in 1993?
Ensure brevity in your answer.  1.08. What is the ratio of the Number of enrolments of both sexes of United Arab Emirates in 1992 to that in 1993?
Offer a very short reply. 0.86. What is the ratio of the Number of enrolments of both sexes in Finland in 1992 to that in 1994?
Give a very brief answer. 0.95. What is the ratio of the Number of enrolments of both sexes of Iceland in 1992 to that in 1994?
Your answer should be very brief. 0.89. What is the ratio of the Number of enrolments of both sexes in Kazakhstan in 1992 to that in 1994?
Offer a terse response. 1.15. What is the ratio of the Number of enrolments of both sexes of United Arab Emirates in 1992 to that in 1994?
Your answer should be compact. 0.78. What is the ratio of the Number of enrolments of both sexes of Finland in 1993 to that in 1994?
Provide a short and direct response. 0.95. What is the ratio of the Number of enrolments of both sexes of Iceland in 1993 to that in 1994?
Offer a very short reply. 0.87. What is the ratio of the Number of enrolments of both sexes in Kazakhstan in 1993 to that in 1994?
Offer a very short reply. 1.07. What is the ratio of the Number of enrolments of both sexes of United Arab Emirates in 1993 to that in 1994?
Provide a succinct answer. 0.91. What is the difference between the highest and the second highest Number of enrolments of both sexes in Finland?
Provide a short and direct response. 6212. What is the difference between the highest and the second highest Number of enrolments of both sexes of Iceland?
Offer a very short reply. 137. What is the difference between the highest and the second highest Number of enrolments of both sexes in Kazakhstan?
Give a very brief answer. 4100. What is the difference between the highest and the second highest Number of enrolments of both sexes in United Arab Emirates?
Provide a short and direct response. 103. What is the difference between the highest and the lowest Number of enrolments of both sexes of Finland?
Give a very brief answer. 2.83e+04. What is the difference between the highest and the lowest Number of enrolments of both sexes in Iceland?
Provide a succinct answer. 1824. What is the difference between the highest and the lowest Number of enrolments of both sexes in Kazakhstan?
Provide a short and direct response. 7.40e+04. What is the difference between the highest and the lowest Number of enrolments of both sexes of United Arab Emirates?
Offer a very short reply. 721. 